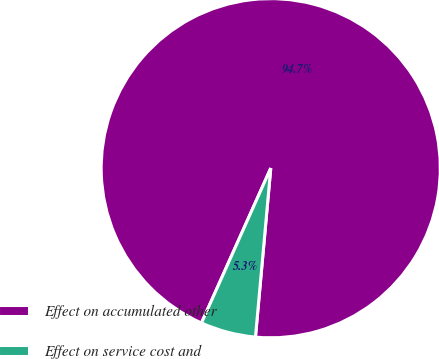<chart> <loc_0><loc_0><loc_500><loc_500><pie_chart><fcel>Effect on accumulated other<fcel>Effect on service cost and<nl><fcel>94.74%<fcel>5.26%<nl></chart> 